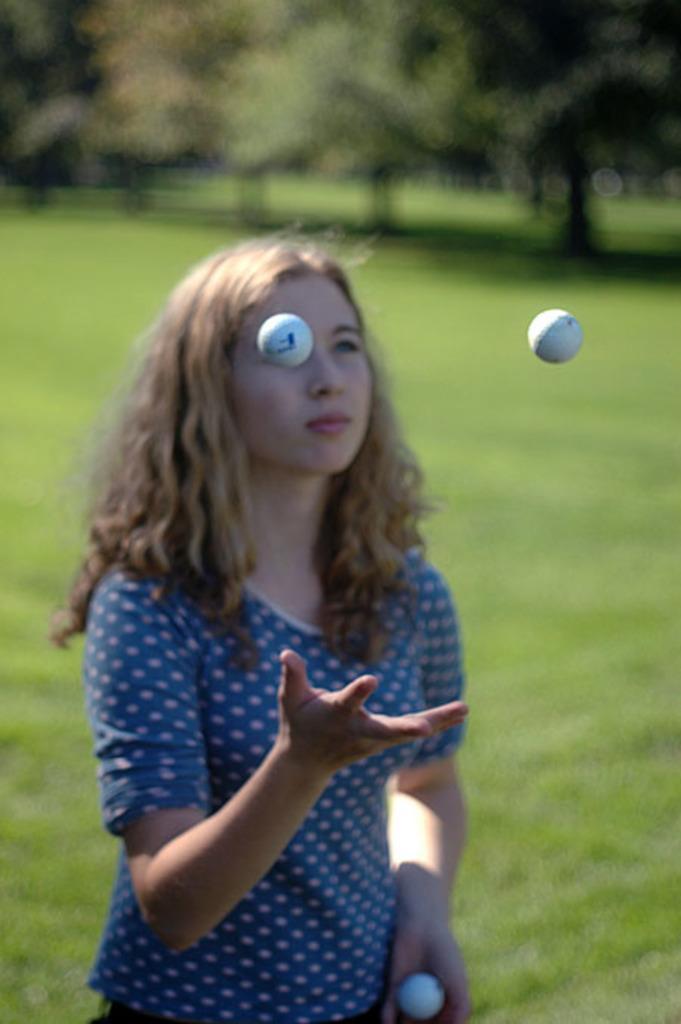Please provide a concise description of this image. This picture is slightly blurred, where I can see a person wearing a blue color dress is holding a ball in her hands and here I can see two balls in the air. In the background, I can see the grass and trees. 